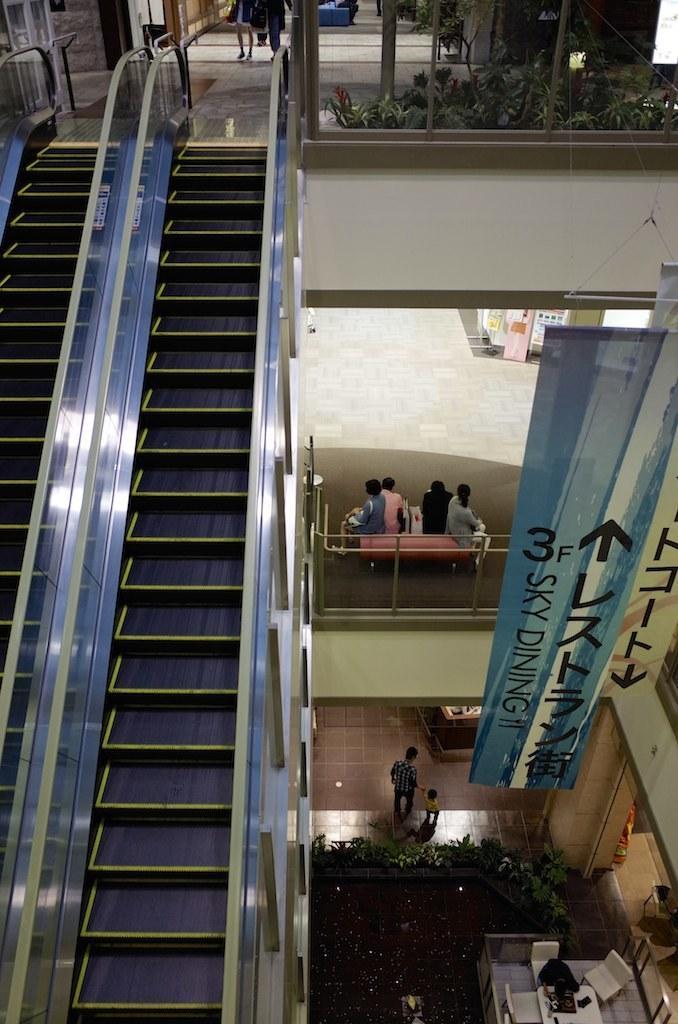Can you describe this image briefly? In the foreground of this image, on the left, there are escalators. At the top, there are few plants behind the railing. On the right, there are banners, few people sitting on the couch, plants, two people walking on the floor, chairs, table on which, there are few objects. 